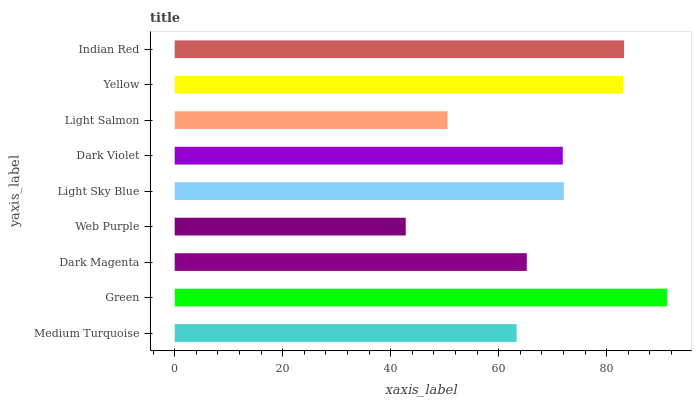Is Web Purple the minimum?
Answer yes or no. Yes. Is Green the maximum?
Answer yes or no. Yes. Is Dark Magenta the minimum?
Answer yes or no. No. Is Dark Magenta the maximum?
Answer yes or no. No. Is Green greater than Dark Magenta?
Answer yes or no. Yes. Is Dark Magenta less than Green?
Answer yes or no. Yes. Is Dark Magenta greater than Green?
Answer yes or no. No. Is Green less than Dark Magenta?
Answer yes or no. No. Is Dark Violet the high median?
Answer yes or no. Yes. Is Dark Violet the low median?
Answer yes or no. Yes. Is Green the high median?
Answer yes or no. No. Is Green the low median?
Answer yes or no. No. 